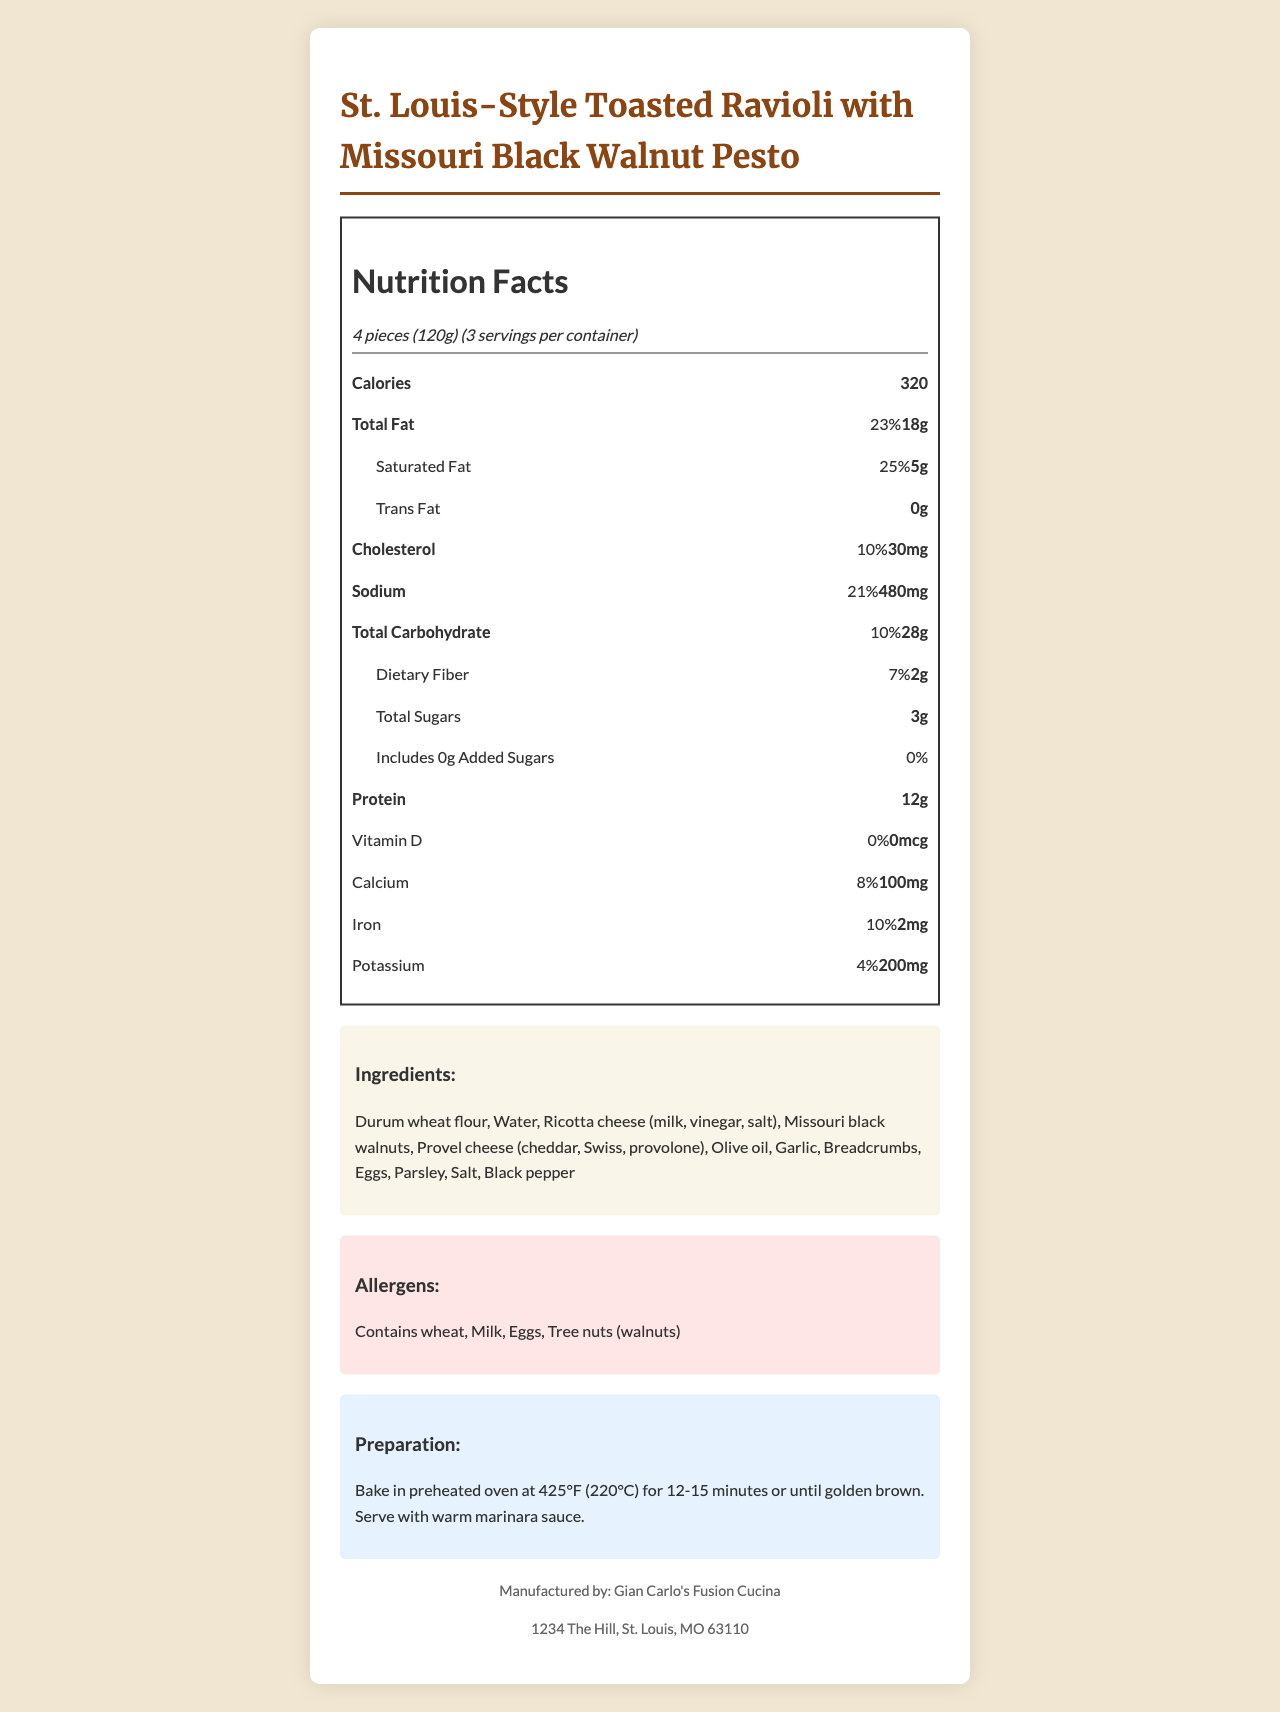what is the serving size? The serving size is listed at the top of the nutrition label as "4 pieces (120g)".
Answer: 4 pieces (120g) how many total calories are there per serving? The label clearly states that there are 320 calories per serving.
Answer: 320 how many servings are in the entire container? The document mentions there are 3 servings per container.
Answer: 3 how much total fat is in one serving? The total fat content per serving is listed as 18g.
Answer: 18g how much calcium does one serving provide in terms of daily value percentage? The calcium daily value percentage per serving is listed as 8%.
Answer: 8% what vitamin is present in the smallest amount in one serving? Vitamin D is listed with an amount of 0mcg and 0% daily value, making it the smallest among the listed vitamins and minerals.
Answer: Vitamin D how much dietary fiber is included in one serving? The dietary fiber content per serving is mentioned as 2g.
Answer: 2g what is the preparation method for the dish? The preparation instructions are listed under the "Preparation" section at the bottom of the document.
Answer: Bake in preheated oven at 425°F (220°C) for 12-15 minutes or until golden brown. Serve with warm marinara sauce. which ingredient is not listed on the allergy information? A. Wheat B. Milk C. Soy D. Tree nuts The allergen information lists wheat, milk, eggs, and tree nuts (walnuts), but not soy.
Answer: C. Soy how many grams of total sugars are in one serving? The amount of total sugars per serving is mentioned as 3g.
Answer: 3g are there any added sugars in the dish? The label specifies 0 grams of added sugars, indicating there are no added sugars in the dish.
Answer: No how much sodium does one serving contain? The sodium content per serving is 480mg as stated in the document.
Answer: 480mg what is the main idea of the document? The document is a detailed nutrition facts label providing comprehensive information about the product "St. Louis-Style Toasted Ravioli with Missouri Black Walnut Pesto," including serving size, nutritional values, ingredients, allergens, and preparation guidelines.
Answer: A nutrition facts label for "St. Louis-Style Toasted Ravioli with Missouri Black Walnut Pesto," detailing serving size, nutritional content, ingredients, allergens, and preparation instructions. who is the manufacturer of the product? The manufacturer is listed at the bottom of the document under the "Manufactured by" section.
Answer: Gian Carlo's Fusion Cucina how many grams of protein are present in one serving? The label mentions that one serving contains 12 grams of protein.
Answer: 12g where is the manufacturer located? The address of the manufacturer is mentioned at the bottom of the document.
Answer: 1234 The Hill, St. Louis, MO 63110 how can we determine the cooking time for this dish? The preparation section specifies the cooking time as baking in a preheated oven at 425°F (220°C) for 12-15 minutes.
Answer: Bake for 12-15 minutes does the dish contain any iron? The document states that one serving contains 2mg of iron, which is 10% of the daily value.
Answer: Yes what type of flour is used in the ingredients? The first ingredient listed in the ingredients section is Durum wheat flour.
Answer: Durum wheat flour are there any allergens related to fish in the dish? The allergen section lists wheat, milk, eggs, and tree nuts (walnuts), but no fish.
Answer: No what is the percentage of daily value for cholesterol in one serving? The nutrition label indicates that one serving contains 10% of the daily value for cholesterol.
Answer: 10% how much potassium does one serving provide? The amount of potassium per serving is mentioned as 200mg.
Answer: 200mg how much trans fat is in one serving? The document lists the trans fat content as 0 grams per serving.
Answer: 0g what are the main cheeses used in the dish? A. Cheddar, Gouda, Provolone B. Cheddar, Swiss, Provolone C. Swiss, Asiago, Mozzarella The ingredients list specifies the use of Provel cheese, which is a blend of cheddar, Swiss, and provolone.
Answer: B. Cheddar, Swiss, Provolone does the document indicate any preparation methods other than baking? The preparation section only mentions baking and makes no mention of alternative preparation methods.
Answer: No what type of sauce is recommended to serve with this dish? The preparation instructions suggest serving the dish with warm marinara sauce.
Answer: Marinara sauce what other Italian ingredients might you add to this fusion dish based on your personal preferences? The document does not provide specific recommendations for additional Italian ingredients; this is subjective and based on personal preferences.
Answer: Not enough information 